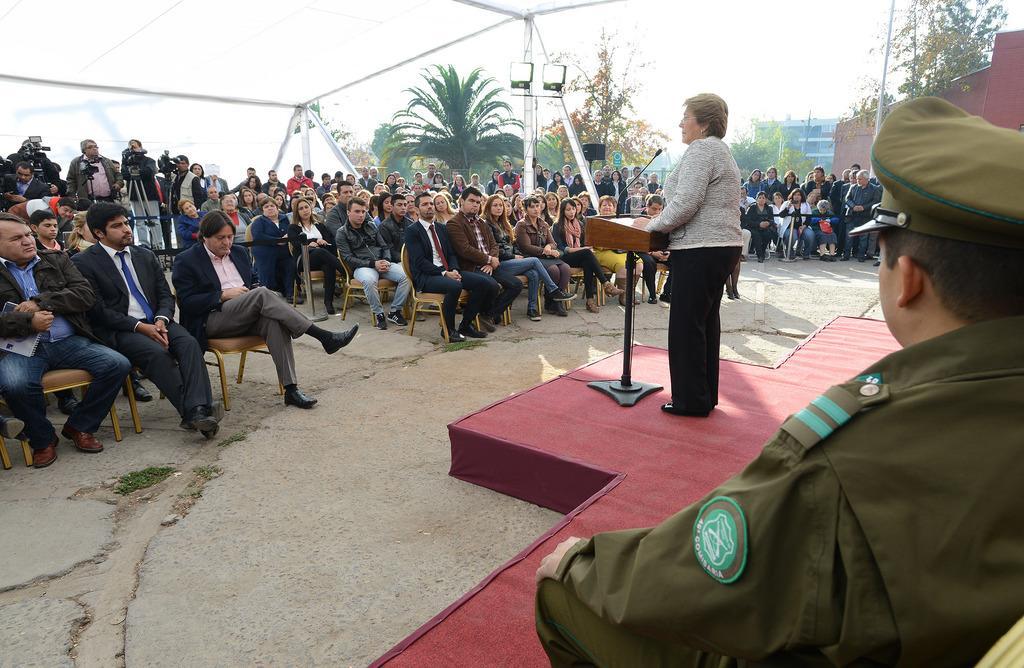How would you summarize this image in a sentence or two? On the right side of the image we can see one person is sitting and he is in a different costume and we can see he is wearing a cap. In the center of the image, we can see one stage. On the stage, we can see one person is standing. In front of her, we can see one stand and one microphone. In the background, we can see the sky, buildings, fences, poles, trees, few people are standing, few people are sitting on the chairs, few people are holding some objects and a few other objects. 